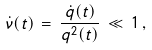Convert formula to latex. <formula><loc_0><loc_0><loc_500><loc_500>\dot { \nu } ( t ) \, = \, \frac { \dot { q } ( t ) } { q ^ { 2 } ( t ) } \, \ll \, 1 \, ,</formula> 